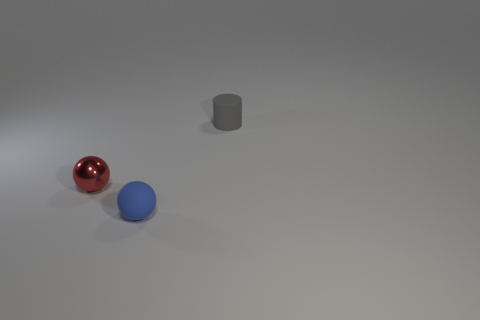Are there any blue spheres made of the same material as the gray thing?
Provide a short and direct response. Yes. Do the object right of the blue thing and the small blue matte object have the same size?
Offer a terse response. Yes. What number of green objects are metal objects or balls?
Offer a terse response. 0. There is a small thing in front of the small red thing; what material is it?
Your answer should be compact. Rubber. What number of small cylinders are in front of the tiny object behind the tiny red metallic ball?
Offer a very short reply. 0. How many blue things have the same shape as the gray thing?
Your response must be concise. 0. What number of tiny blue spheres are there?
Offer a very short reply. 1. There is a rubber thing behind the red metallic thing; what is its color?
Offer a very short reply. Gray. There is a object that is left of the matte thing left of the gray rubber object; what is its color?
Your answer should be compact. Red. The rubber cylinder that is the same size as the blue matte ball is what color?
Make the answer very short. Gray. 